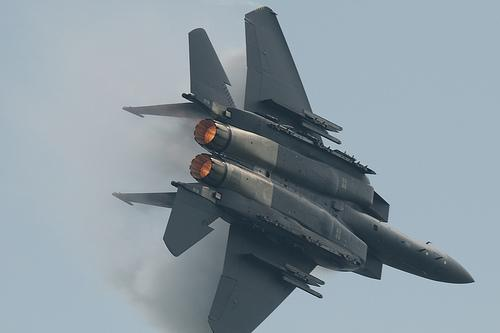Question: who is "driving" this vehicle?
Choices:
A. A chauffer.
B. A driver.
C. A man.
D. A pilot.
Answer with the letter. Answer: D Question: what is in the photo?
Choices:
A. A passenger jet.
B. A helicopter.
C. A yacht.
D. A fighter jet.
Answer with the letter. Answer: D Question: what color are the insides of the jets?
Choices:
A. Orange.
B. Red.
C. Yellow.
D. Green.
Answer with the letter. Answer: A Question: why is the sky like today?
Choices:
A. Cloudy.
B. Sunny.
C. Stormy.
D. Clear.
Answer with the letter. Answer: D Question: how is the plane positioned in the sky?
Choices:
A. Straight.
B. Sideways.
C. Tilting.
D. Upside down.
Answer with the letter. Answer: B 